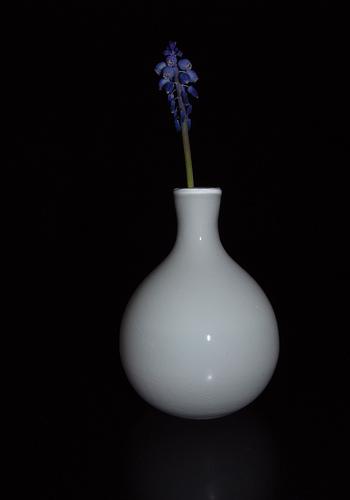What color is the vase?
Give a very brief answer. White. What kind vases are shown?
Give a very brief answer. White. How many vases are there?
Be succinct. 1. What is the focal point of the photo?
Concise answer only. Vase. Is there anything in the vase?
Answer briefly. Yes. How many  flowers are in the vase?
Concise answer only. 1. What time of day was this picture taken?
Answer briefly. Night. How many items are red?
Quick response, please. 0. What is in the vase?
Write a very short answer. Flower. What is the primary color of the vase?
Answer briefly. White. How many flowers are in the vase?
Concise answer only. 1. Is this flower a bluebell?
Give a very brief answer. Yes. 